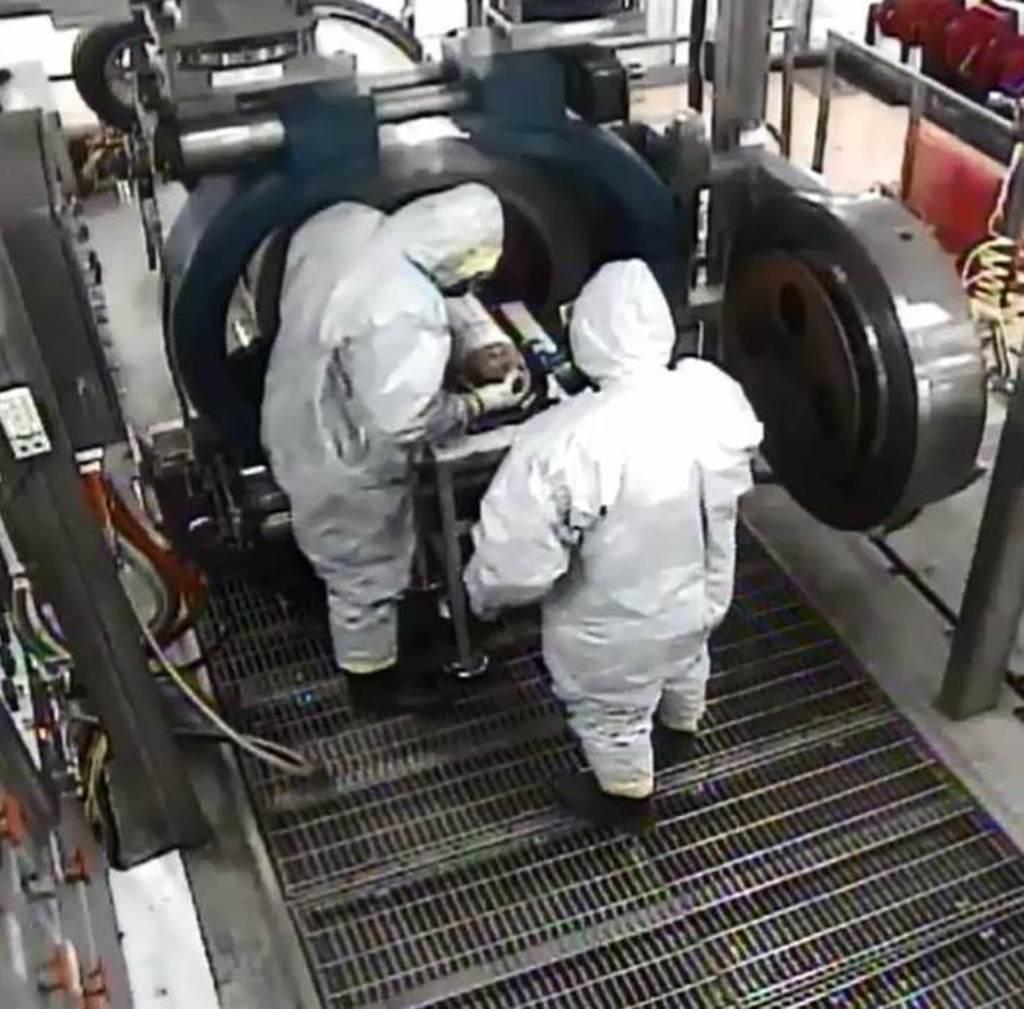What are the two people in the image doing? The two people in the image are working. What else can be seen in the image besides the people? There are machines in the image. Can you describe the mesh at the bottom of the image? Yes, there is a mesh at the bottom of the image. Where is the duck hiding in the image? There is no duck present in the image. What type of recess is visible in the image? There is no recess present in the image. 